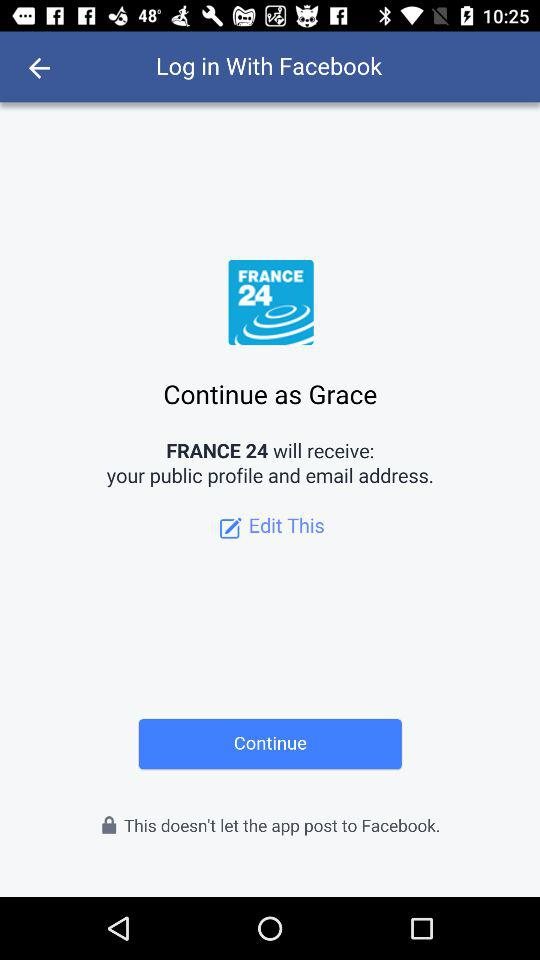What application is asking for permission? The application is "FRANCE 24". 